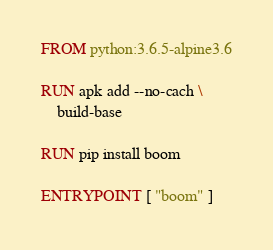Convert code to text. <code><loc_0><loc_0><loc_500><loc_500><_Dockerfile_>FROM python:3.6.5-alpine3.6

RUN apk add --no-cach \
    build-base

RUN pip install boom

ENTRYPOINT [ "boom" ]</code> 